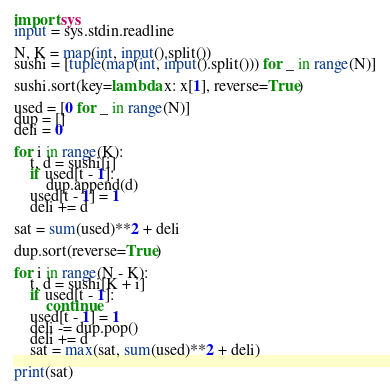<code> <loc_0><loc_0><loc_500><loc_500><_Python_>import sys
input = sys.stdin.readline

N, K = map(int, input().split())
sushi = [tuple(map(int, input().split())) for _ in range(N)]

sushi.sort(key=lambda x: x[1], reverse=True)

used = [0 for _ in range(N)]
dup = []
deli = 0

for i in range(K):
    t, d = sushi[i]
    if used[t - 1]:
        dup.append(d)
    used[t - 1] = 1
    deli += d

sat = sum(used)**2 + deli

dup.sort(reverse=True)

for i in range(N - K):
    t, d = sushi[K + i]
    if used[t - 1]:
        continue
    used[t - 1] = 1
    deli -= dup.pop()
    deli += d
    sat = max(sat, sum(used)**2 + deli)

print(sat)</code> 